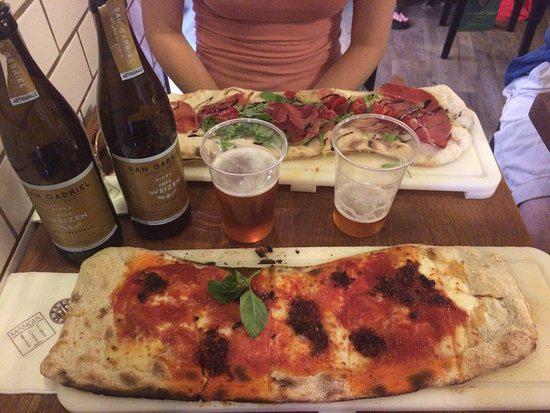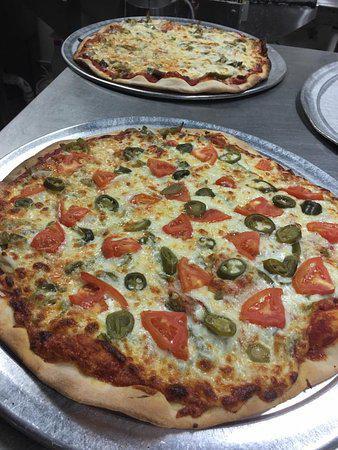The first image is the image on the left, the second image is the image on the right. Evaluate the accuracy of this statement regarding the images: "Each image contains two roundish pizzas with no slices missing.". Is it true? Answer yes or no. No. The first image is the image on the left, the second image is the image on the right. Examine the images to the left and right. Is the description "A fork and knife have been placed next to the pizza in one of the pictures." accurate? Answer yes or no. No. 